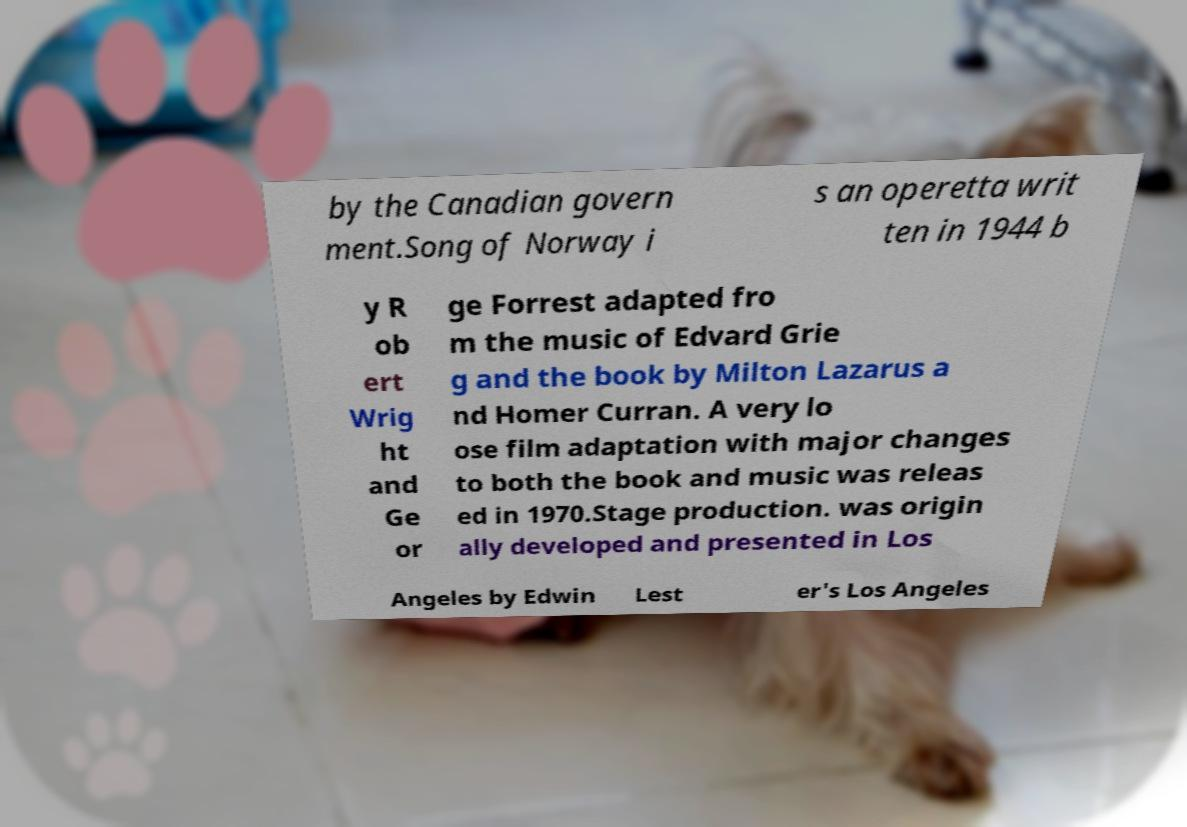For documentation purposes, I need the text within this image transcribed. Could you provide that? by the Canadian govern ment.Song of Norway i s an operetta writ ten in 1944 b y R ob ert Wrig ht and Ge or ge Forrest adapted fro m the music of Edvard Grie g and the book by Milton Lazarus a nd Homer Curran. A very lo ose film adaptation with major changes to both the book and music was releas ed in 1970.Stage production. was origin ally developed and presented in Los Angeles by Edwin Lest er's Los Angeles 